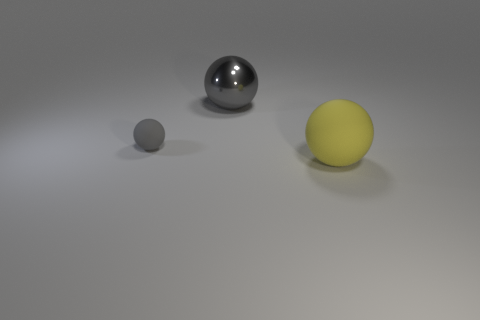Subtract all large yellow spheres. How many spheres are left? 2 Add 2 large rubber balls. How many objects exist? 5 Subtract all yellow balls. How many balls are left? 2 Subtract all cyan balls. Subtract all blue cylinders. How many balls are left? 3 Subtract all brown cubes. How many brown spheres are left? 0 Subtract all small gray blocks. Subtract all shiny balls. How many objects are left? 2 Add 2 tiny spheres. How many tiny spheres are left? 3 Add 2 gray rubber things. How many gray rubber things exist? 3 Subtract 0 blue cubes. How many objects are left? 3 